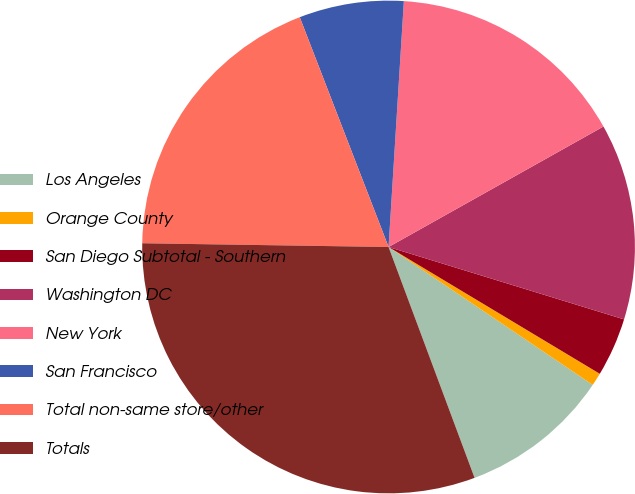Convert chart. <chart><loc_0><loc_0><loc_500><loc_500><pie_chart><fcel>Los Angeles<fcel>Orange County<fcel>San Diego Subtotal - Southern<fcel>Washington DC<fcel>New York<fcel>San Francisco<fcel>Total non-same store/other<fcel>Totals<nl><fcel>9.87%<fcel>0.85%<fcel>3.86%<fcel>12.88%<fcel>15.88%<fcel>6.86%<fcel>18.89%<fcel>30.92%<nl></chart> 